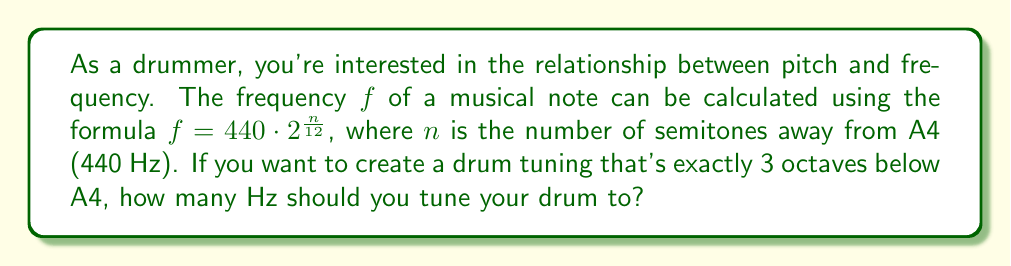Give your solution to this math problem. Let's approach this step-by-step:

1) First, recall that an octave represents a doubling or halving of frequency. Three octaves below means we need to divide by 2 three times.

2) In terms of semitones, one octave is 12 semitones. So, 3 octaves below would be -36 semitones.

3) We can use the given formula: $f = 440 \cdot 2^{\frac{n}{12}}$

4) Substituting $n = -36$:

   $f = 440 \cdot 2^{\frac{-36}{12}}$

5) Simplify the exponent:
   
   $f = 440 \cdot 2^{-3}$

6) Calculate:
   
   $f = 440 \cdot \frac{1}{8} = 55$

Therefore, a drum tuned 3 octaves below A4 should have a frequency of 55 Hz.
Answer: 55 Hz 